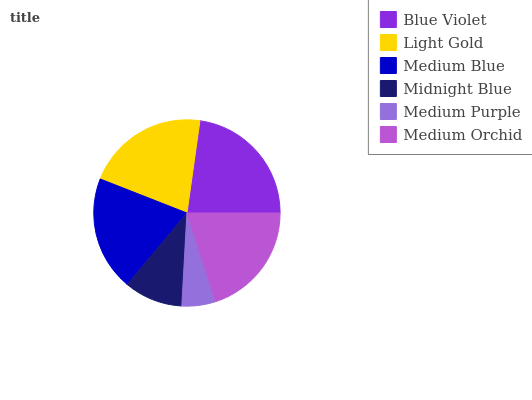Is Medium Purple the minimum?
Answer yes or no. Yes. Is Blue Violet the maximum?
Answer yes or no. Yes. Is Light Gold the minimum?
Answer yes or no. No. Is Light Gold the maximum?
Answer yes or no. No. Is Blue Violet greater than Light Gold?
Answer yes or no. Yes. Is Light Gold less than Blue Violet?
Answer yes or no. Yes. Is Light Gold greater than Blue Violet?
Answer yes or no. No. Is Blue Violet less than Light Gold?
Answer yes or no. No. Is Medium Orchid the high median?
Answer yes or no. Yes. Is Medium Blue the low median?
Answer yes or no. Yes. Is Light Gold the high median?
Answer yes or no. No. Is Blue Violet the low median?
Answer yes or no. No. 